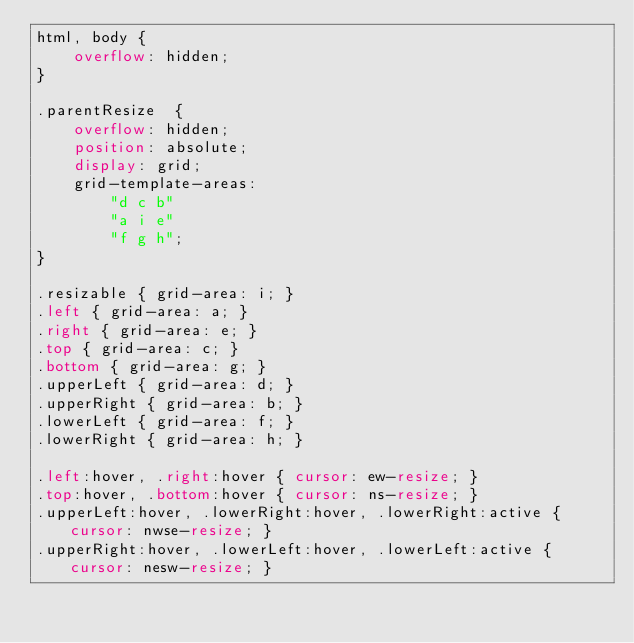Convert code to text. <code><loc_0><loc_0><loc_500><loc_500><_CSS_>html, body {
    overflow: hidden;
}

.parentResize  {
    overflow: hidden;
    position: absolute;
    display: grid;
    grid-template-areas:
        "d c b"
        "a i e"
        "f g h";
}

.resizable { grid-area: i; }
.left { grid-area: a; }
.right { grid-area: e; }
.top { grid-area: c; }
.bottom { grid-area: g; }
.upperLeft { grid-area: d; }
.upperRight { grid-area: b; }
.lowerLeft { grid-area: f; }
.lowerRight { grid-area: h; }

.left:hover, .right:hover { cursor: ew-resize; }
.top:hover, .bottom:hover { cursor: ns-resize; }
.upperLeft:hover, .lowerRight:hover, .lowerRight:active { cursor: nwse-resize; }
.upperRight:hover, .lowerLeft:hover, .lowerLeft:active { cursor: nesw-resize; }</code> 